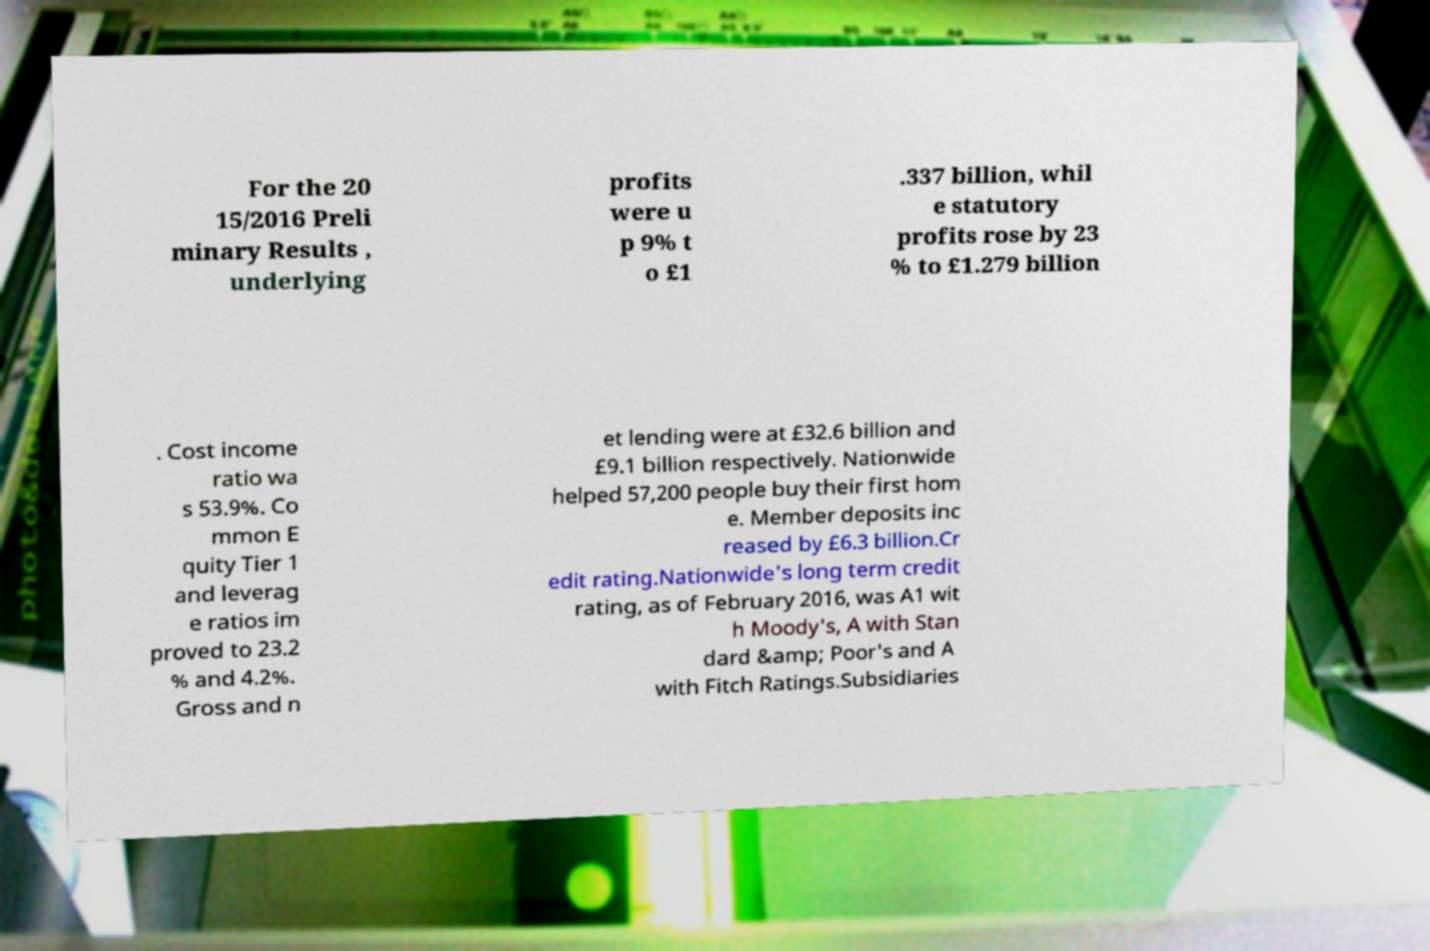I need the written content from this picture converted into text. Can you do that? For the 20 15/2016 Preli minary Results , underlying profits were u p 9% t o £1 .337 billion, whil e statutory profits rose by 23 % to £1.279 billion . Cost income ratio wa s 53.9%. Co mmon E quity Tier 1 and leverag e ratios im proved to 23.2 % and 4.2%. Gross and n et lending were at £32.6 billion and £9.1 billion respectively. Nationwide helped 57,200 people buy their first hom e. Member deposits inc reased by £6.3 billion.Cr edit rating.Nationwide's long term credit rating, as of February 2016, was A1 wit h Moody's, A with Stan dard &amp; Poor's and A with Fitch Ratings.Subsidiaries 